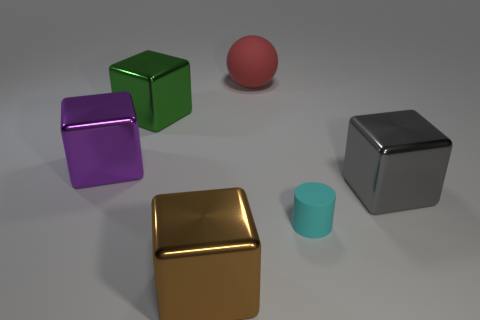The gray shiny thing that is the same size as the purple metal block is what shape? cube 